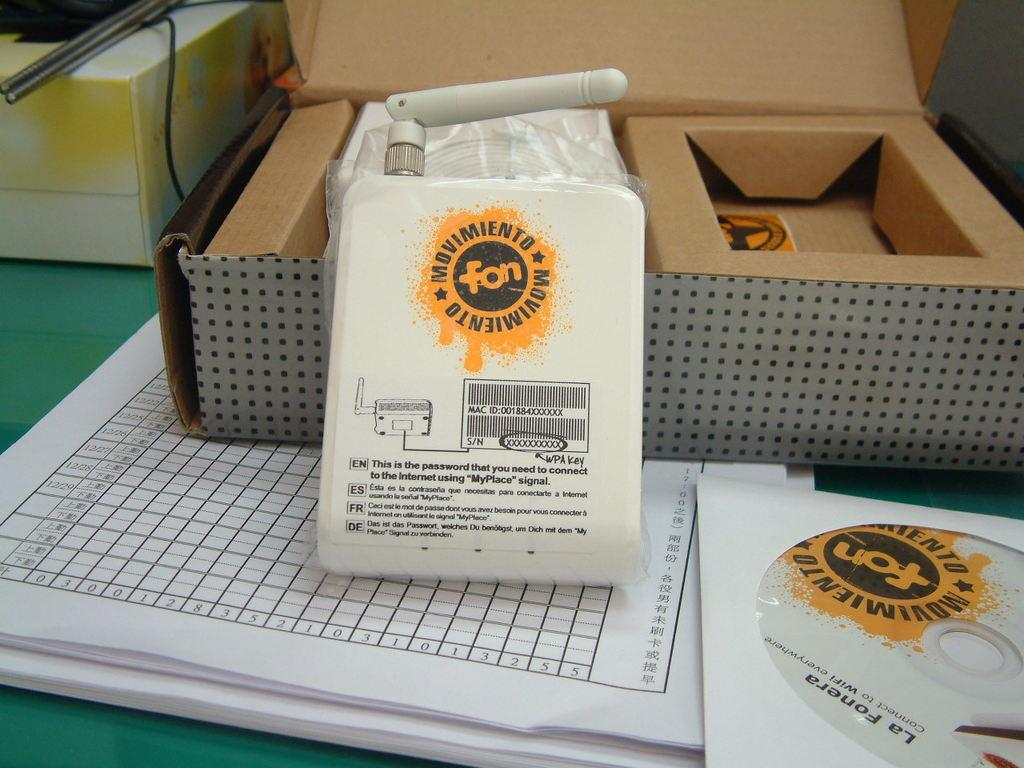<image>
Describe the image concisely. A white bag with an orange emblem has fon in the middle of it. 